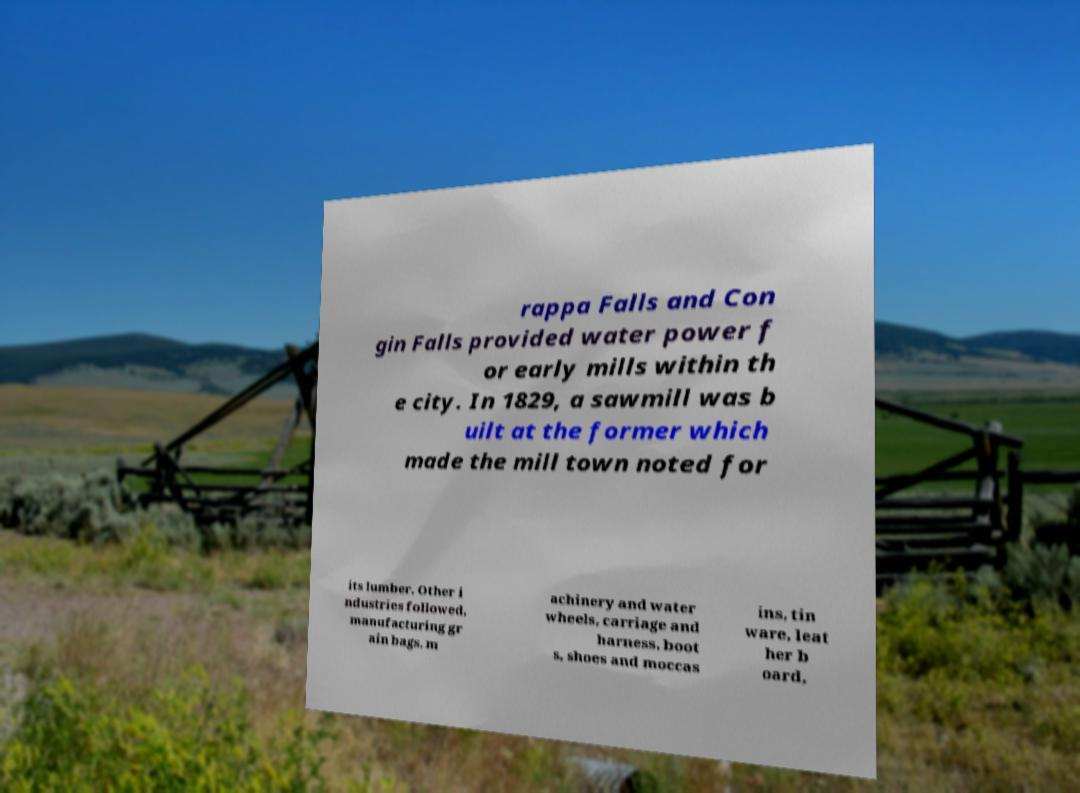Please read and relay the text visible in this image. What does it say? rappa Falls and Con gin Falls provided water power f or early mills within th e city. In 1829, a sawmill was b uilt at the former which made the mill town noted for its lumber. Other i ndustries followed, manufacturing gr ain bags, m achinery and water wheels, carriage and harness, boot s, shoes and moccas ins, tin ware, leat her b oard, 